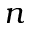<formula> <loc_0><loc_0><loc_500><loc_500>n</formula> 